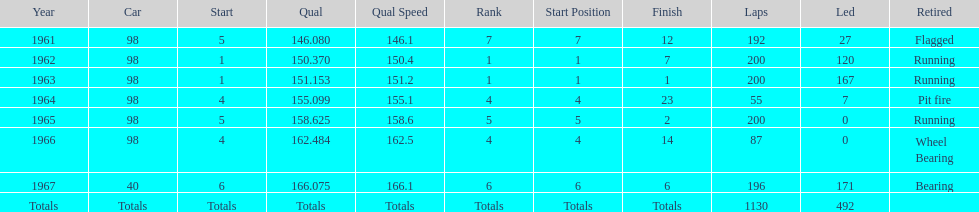Number of times to finish the races running. 3. 